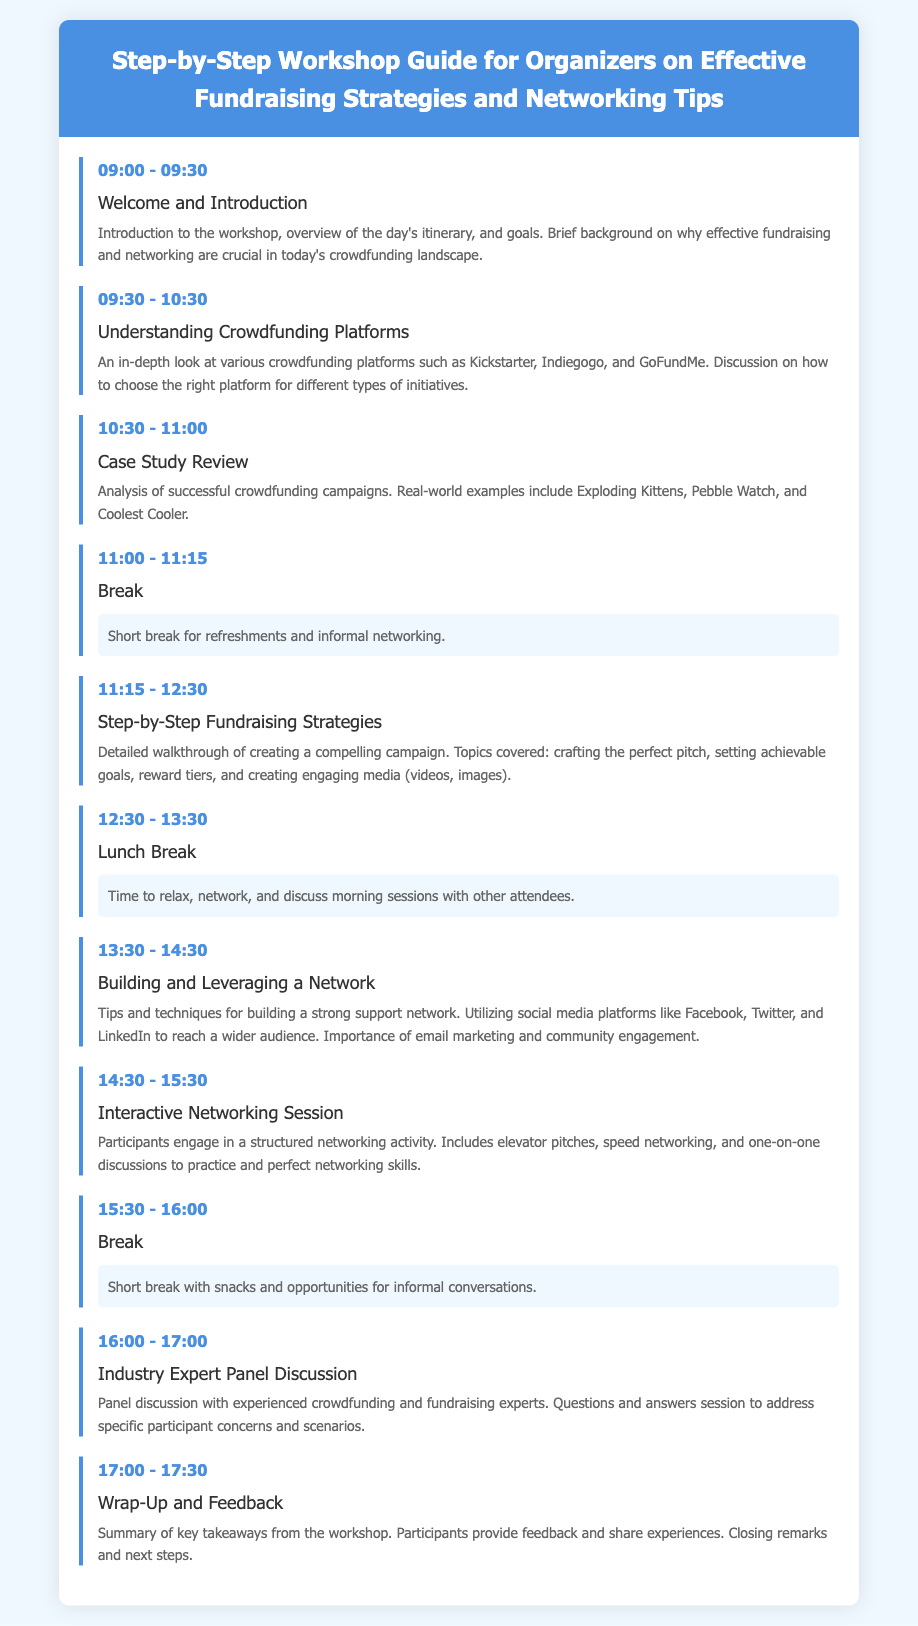What time does the workshop start? The workshop starts at 09:00 according to the itinerary.
Answer: 09:00 What is the title of the workshop? The title of the workshop is stated in the header section of the document.
Answer: Step-by-Step Workshop Guide for Organizers on Effective Fundraising Strategies and Networking Tips What are the successful campaign examples mentioned? The case study review section lists several successful crowdfunding campaigns as examples.
Answer: Exploding Kittens, Pebble Watch, Coolest Cooler How long is the lunch break? The duration of the lunch break can be found in the itinerary.
Answer: 1 hour What activity takes place after the lunch break? The next activity after lunch is detailed directly in the itinerary.
Answer: Building and Leveraging a Network What is the purpose of the Interactive Networking Session? The purpose of this session is to engage participants in networking skills.
Answer: Practice and perfect networking skills How many major sessions are outlined before the wrap-up? The number of major sessions can be counted from the itinerary listed activities before the wrap-up.
Answer: 8 sessions Which platform is mentioned as part of building a network? The specific social media platform highlighted in the networking tips is listed.
Answer: Facebook, Twitter, LinkedIn What type of feedback is given at the end of the workshop? The final session focuses on summarizing experiences and collecting participant feedback.
Answer: Feedback and share experiences 